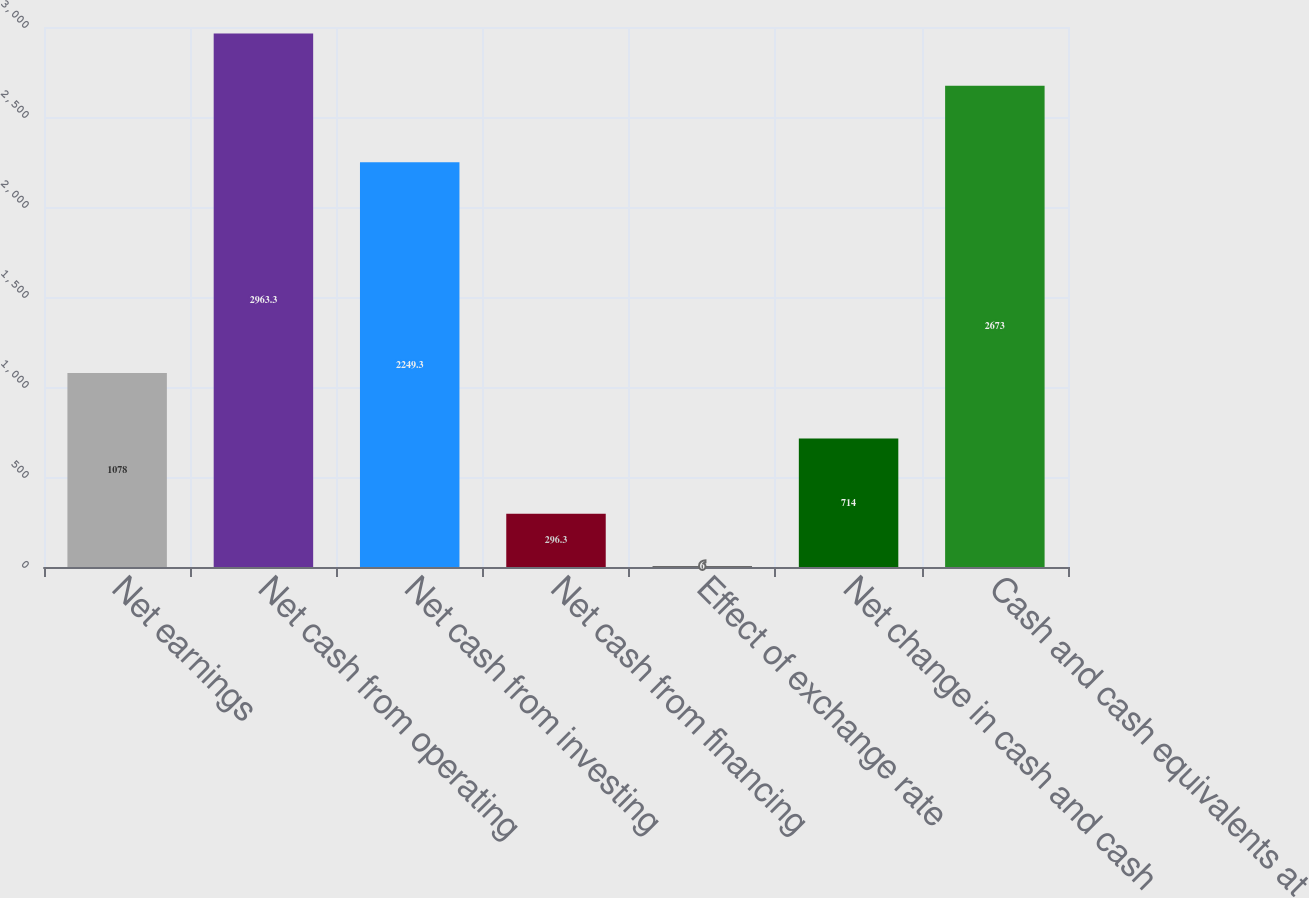Convert chart to OTSL. <chart><loc_0><loc_0><loc_500><loc_500><bar_chart><fcel>Net earnings<fcel>Net cash from operating<fcel>Net cash from investing<fcel>Net cash from financing<fcel>Effect of exchange rate<fcel>Net change in cash and cash<fcel>Cash and cash equivalents at<nl><fcel>1078<fcel>2963.3<fcel>2249.3<fcel>296.3<fcel>6<fcel>714<fcel>2673<nl></chart> 